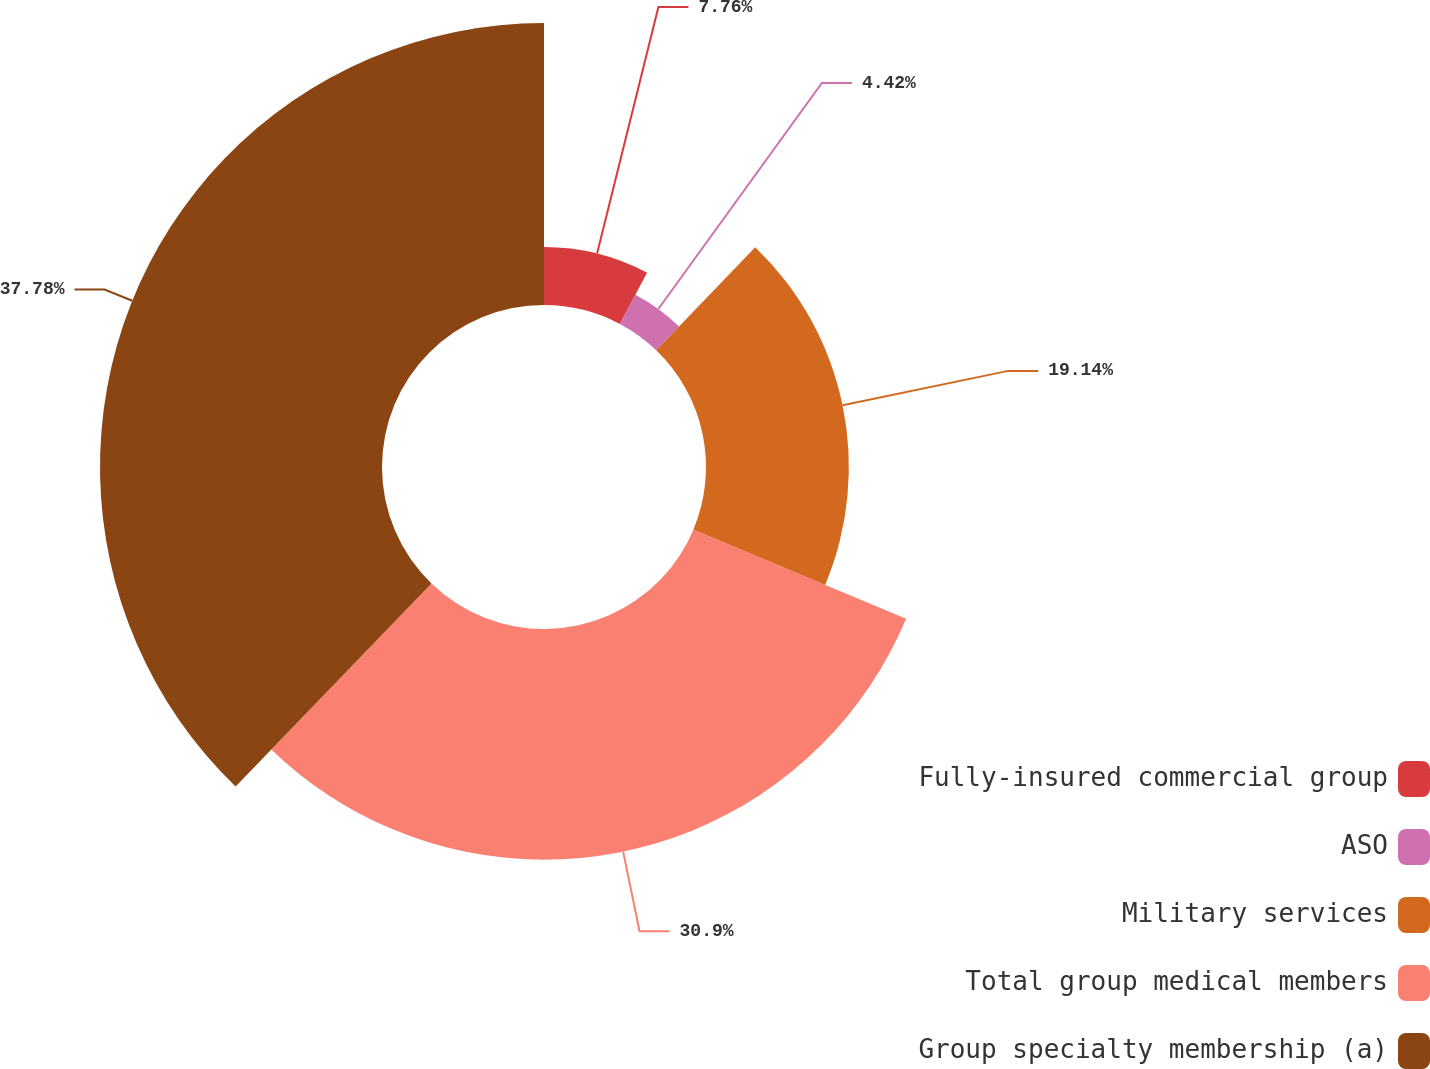Convert chart. <chart><loc_0><loc_0><loc_500><loc_500><pie_chart><fcel>Fully-insured commercial group<fcel>ASO<fcel>Military services<fcel>Total group medical members<fcel>Group specialty membership (a)<nl><fcel>7.76%<fcel>4.42%<fcel>19.14%<fcel>30.9%<fcel>37.78%<nl></chart> 